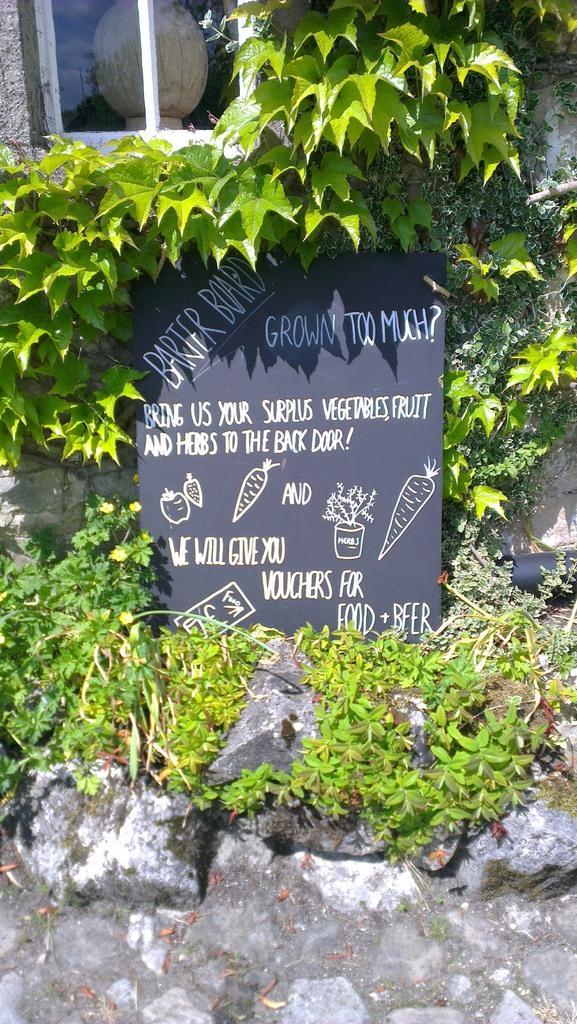Can you describe this image briefly? In this picture we can observe a black color board. There is some text on the board. There are some stones and plants. We can observe a window in the background. 